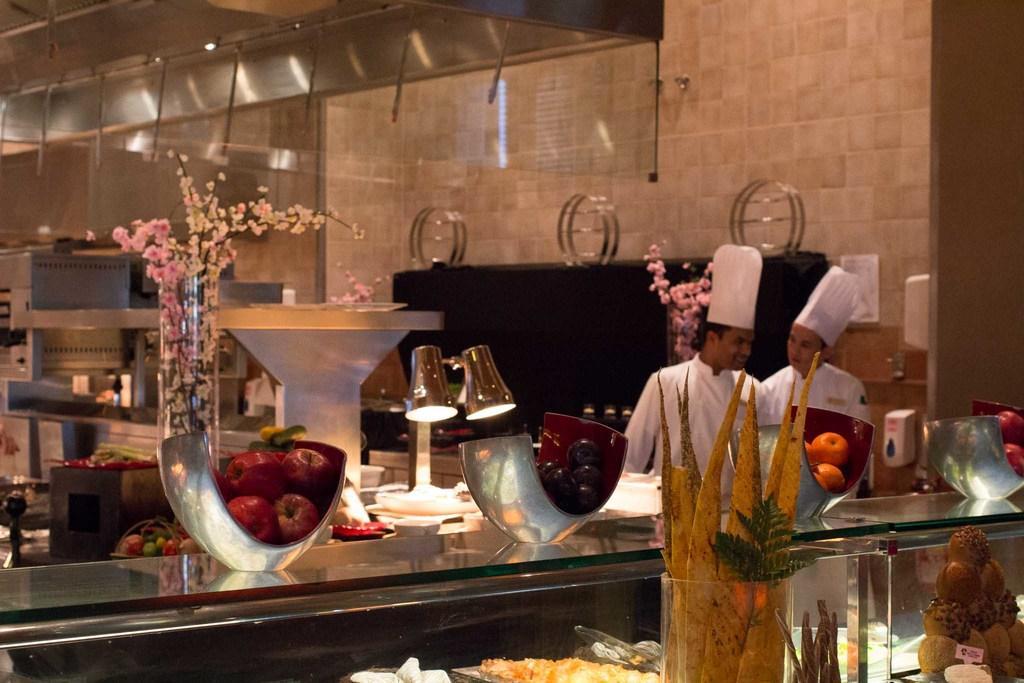Can you describe this image briefly? This picture shows a kitchen and we see fruits and some food in the tray and we see couple of men wore caps on their heads and we see flower pots and few vegetables and couple of lights to the stand. 